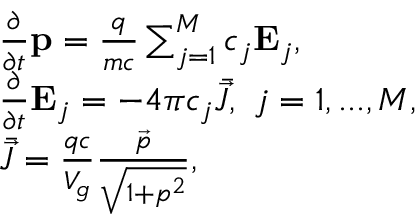Convert formula to latex. <formula><loc_0><loc_0><loc_500><loc_500>\begin{array} { r l } & { \frac { \partial } { \partial t } p = \frac { q } { m c } \sum _ { j = 1 } ^ { M } c _ { j } E _ { j } , } \\ & { \frac { \partial } { \partial t } E _ { j } = - 4 \pi c _ { j } \bar { \vec { J } } , \ j = 1 , \dots , M , } \\ & { \bar { \vec { J } } = \frac { q c } { V _ { g } } \frac { \vec { p } } { \sqrt { 1 + p ^ { 2 } } } , } \end{array}</formula> 